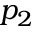<formula> <loc_0><loc_0><loc_500><loc_500>p _ { 2 }</formula> 